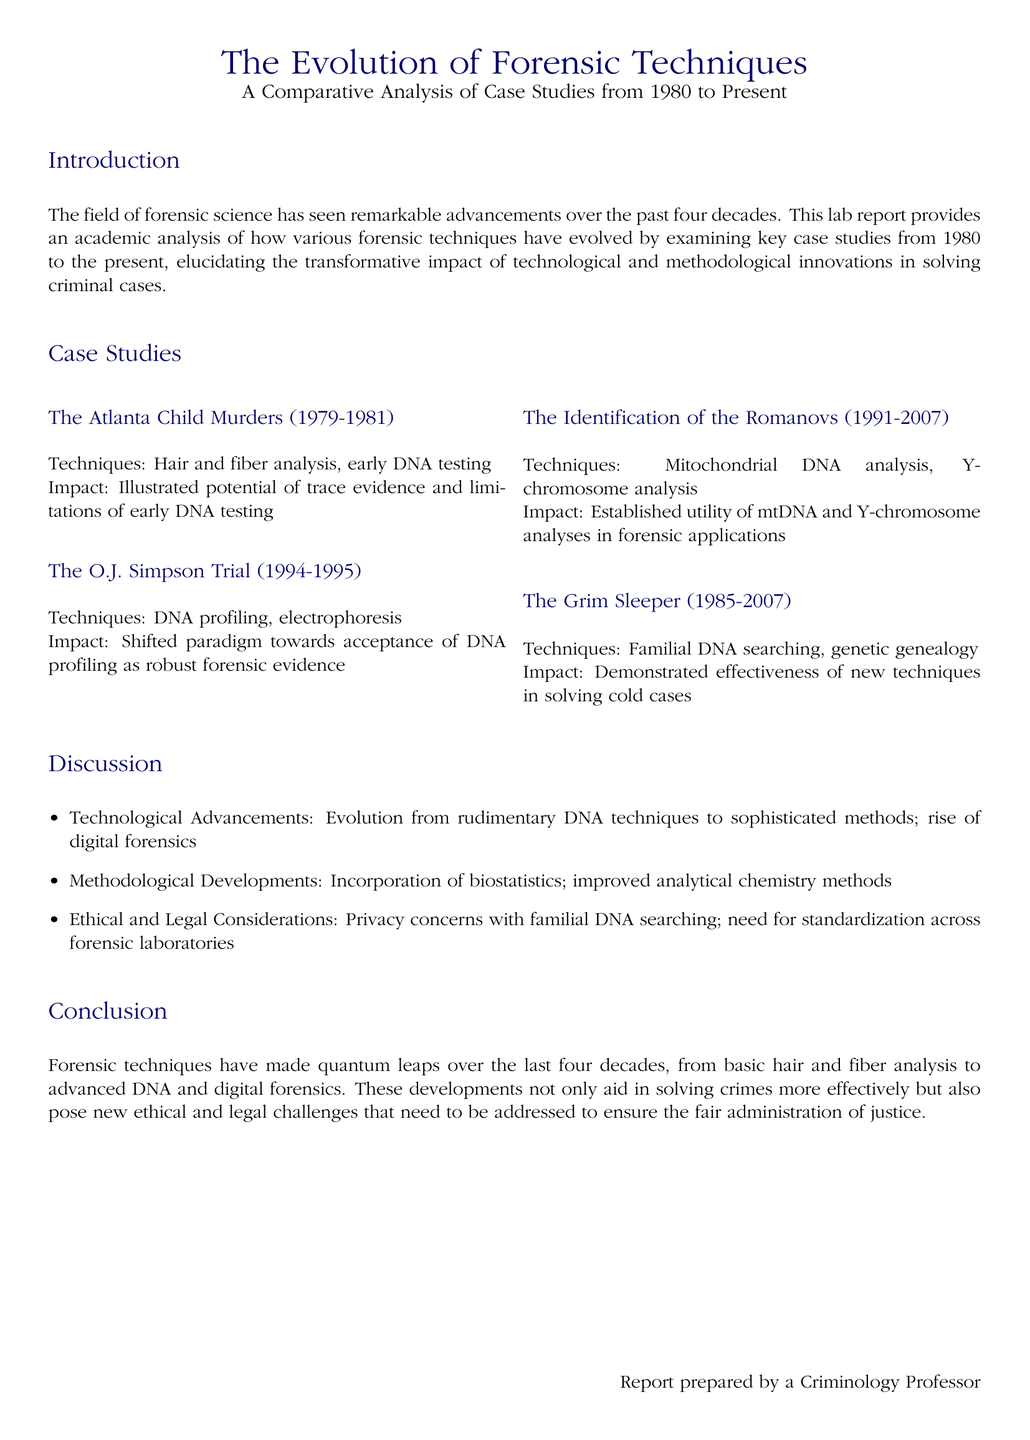What year did the Atlanta Child Murders occur? The document specifies that the Atlanta Child Murders took place from 1979 to 1981.
Answer: 1979-1981 What forensic technique was highlighted in the O.J. Simpson trial? The O.J. Simpson trial is noted for its use of DNA profiling and electrophoresis as key techniques.
Answer: DNA profiling What technique was used in the identification of the Romanovs? The report states that mitochondrial DNA analysis and Y-chromosome analysis were employed in this case.
Answer: Mitochondrial DNA analysis What was a significant impact of the Grim Sleeper case? The document mentions that the Grim Sleeper case demonstrated the effectiveness of new techniques in solving cold cases.
Answer: Effectiveness of new techniques What are two types of advancements discussed in the report? The document highlights technological advancements and methodological developments as key areas of evolution in forensic techniques.
Answer: Technological advancements What ethical concern is associated with familial DNA searching? The report raises privacy concerns as a critical issue related to familial DNA searching.
Answer: Privacy concerns How did forensic techniques evolve from the early days to the present? The document notes a significant evolution from rudimentary DNA techniques to sophisticated methods, including digital forensics.
Answer: Sophisticated methods Who prepared the report? The document specifies that the report was prepared by a criminology professor.
Answer: Criminology Professor What is the purpose of the lab report? The primary purpose is to provide an academic analysis of the evolution of forensic techniques through case studies from 1980 to present.
Answer: Academic analysis 